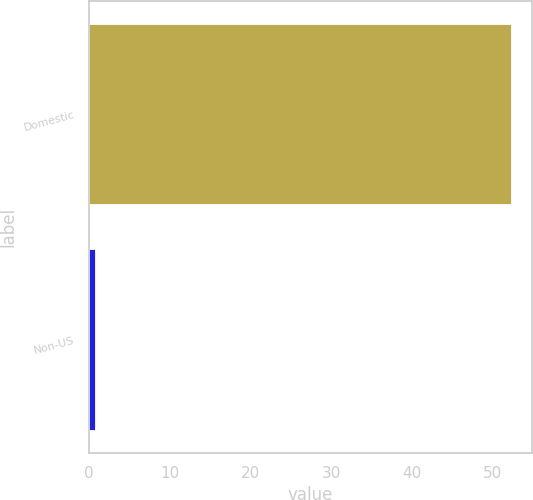<chart> <loc_0><loc_0><loc_500><loc_500><bar_chart><fcel>Domestic<fcel>Non-US<nl><fcel>52.2<fcel>0.8<nl></chart> 